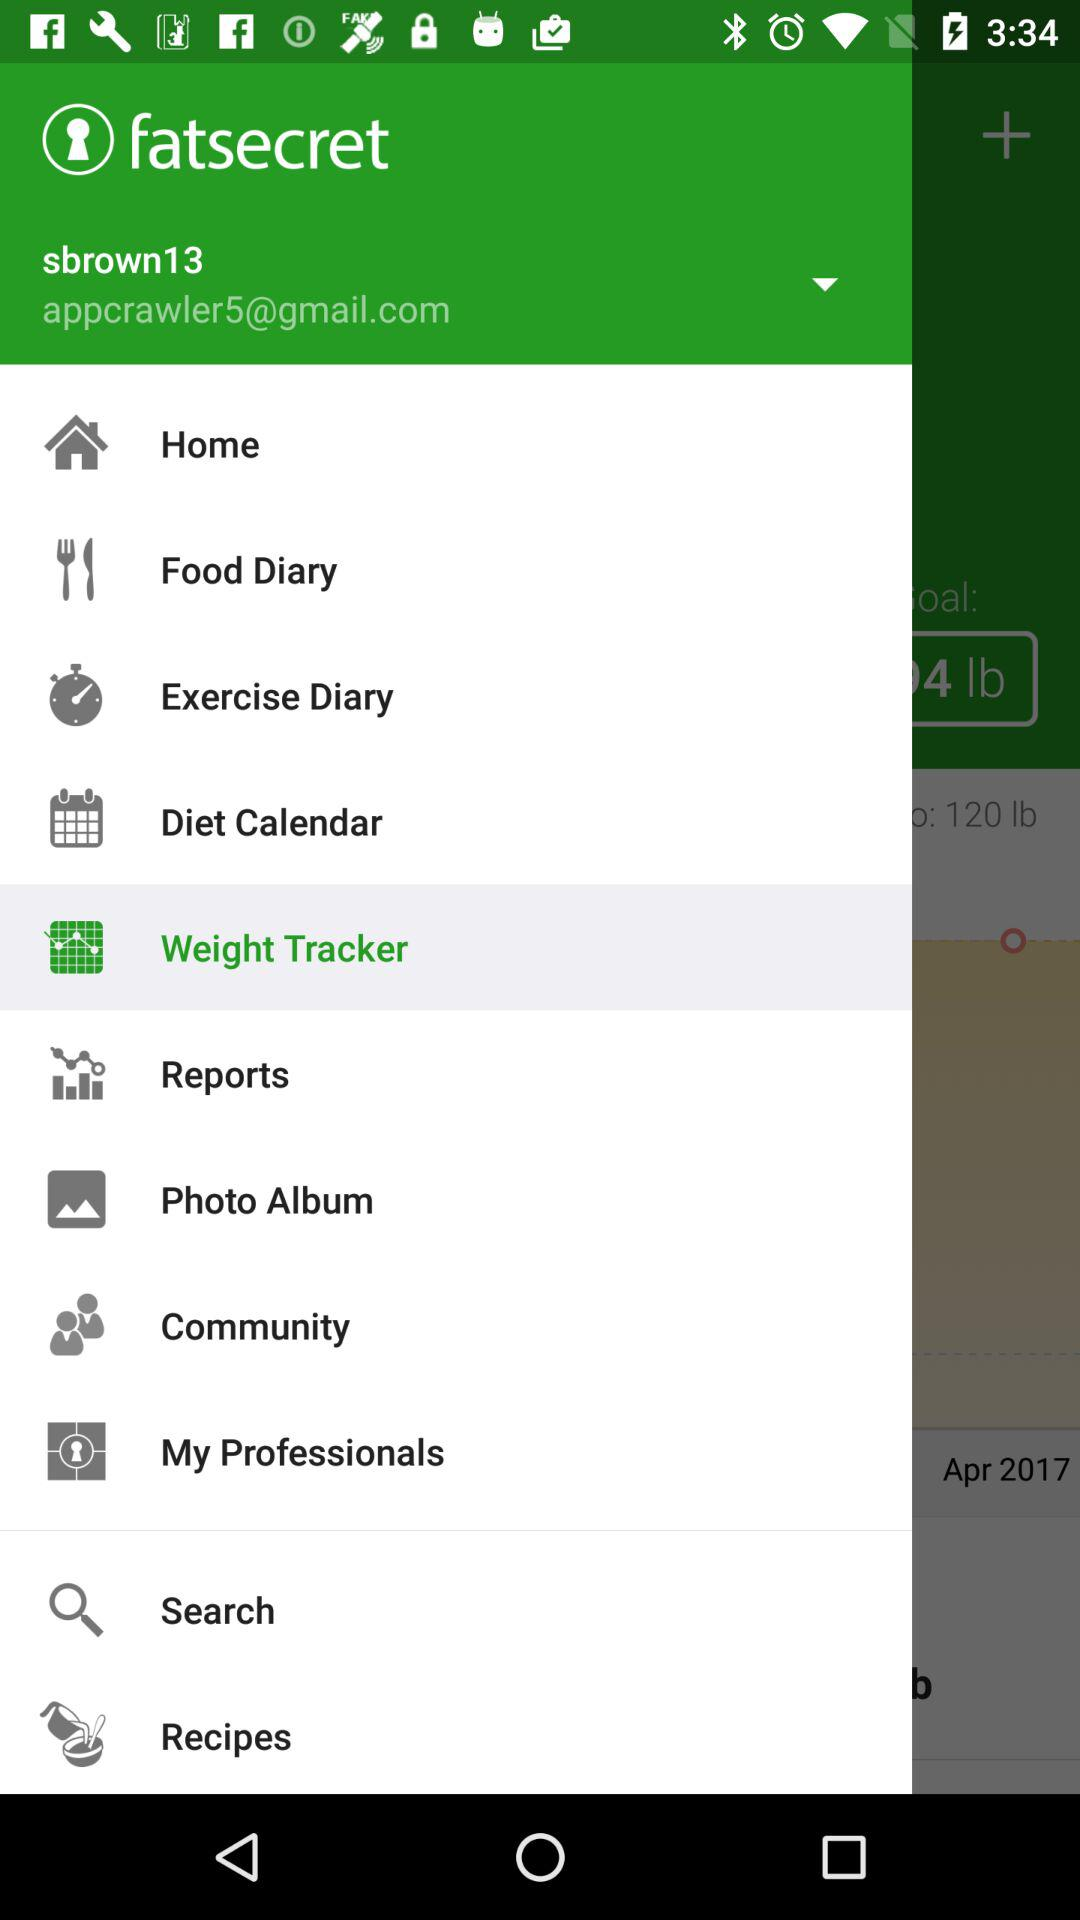What are the items available in the menu? The available items are "Home", "Food Diary", "Exercise Diary", "Diet Calendar", "Weight Tracker", "Reports", "Photo Album", "Community", "My Professionals", "Search" and "Recipes". 